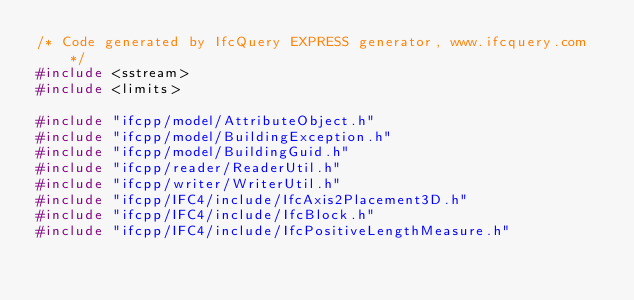<code> <loc_0><loc_0><loc_500><loc_500><_C++_>/* Code generated by IfcQuery EXPRESS generator, www.ifcquery.com */
#include <sstream>
#include <limits>

#include "ifcpp/model/AttributeObject.h"
#include "ifcpp/model/BuildingException.h"
#include "ifcpp/model/BuildingGuid.h"
#include "ifcpp/reader/ReaderUtil.h"
#include "ifcpp/writer/WriterUtil.h"
#include "ifcpp/IFC4/include/IfcAxis2Placement3D.h"
#include "ifcpp/IFC4/include/IfcBlock.h"
#include "ifcpp/IFC4/include/IfcPositiveLengthMeasure.h"</code> 